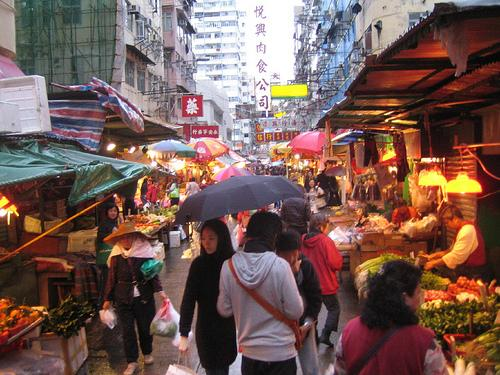What is the occupation of the man in the red vest?

Choices:
A) fashion model
B) produce vendor
C) circus acrobat
D) restaurant chef produce vendor 